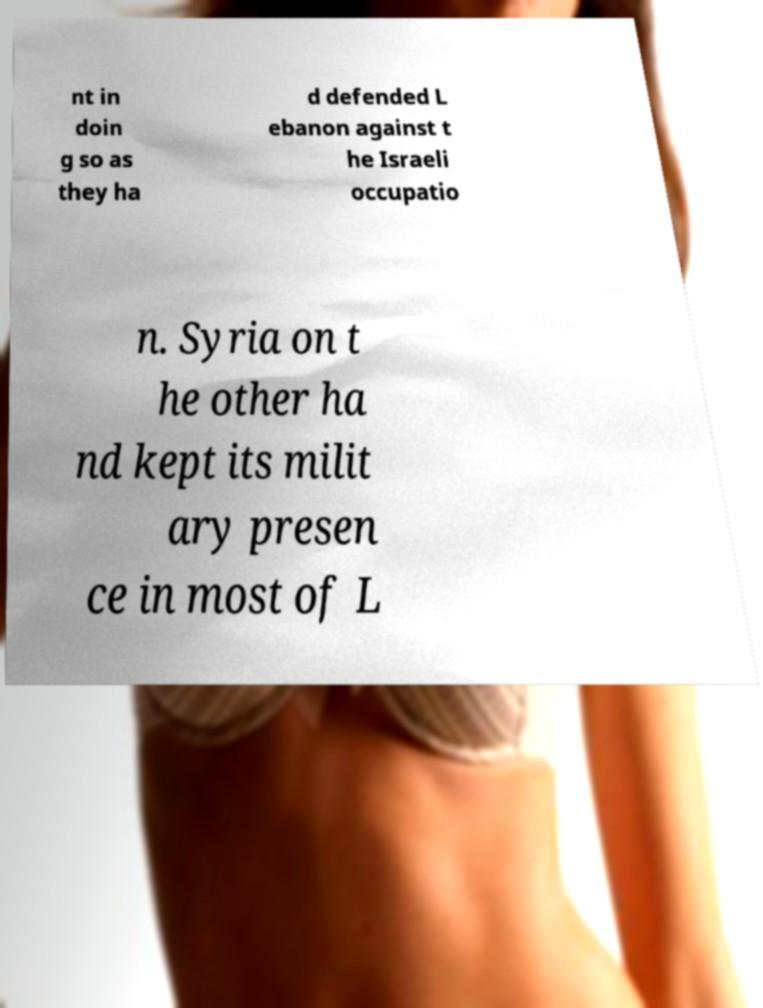Could you assist in decoding the text presented in this image and type it out clearly? nt in doin g so as they ha d defended L ebanon against t he Israeli occupatio n. Syria on t he other ha nd kept its milit ary presen ce in most of L 